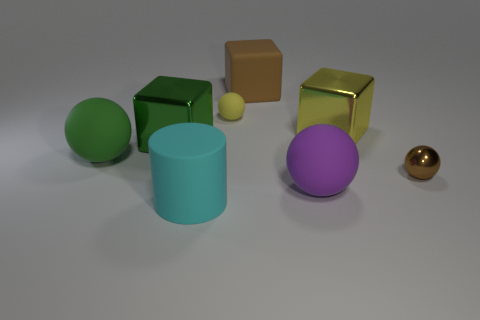What color is the other shiny cube that is the same size as the yellow metallic block?
Provide a short and direct response. Green. What number of things are either purple matte blocks or big matte things?
Your response must be concise. 4. There is a tiny yellow matte thing; are there any large green rubber balls in front of it?
Your answer should be compact. Yes. Is there a yellow thing made of the same material as the big brown block?
Provide a succinct answer. Yes. What size is the shiny thing that is the same color as the rubber cube?
Offer a terse response. Small. What number of spheres are blue matte things or tiny brown things?
Ensure brevity in your answer.  1. Is the number of tiny metallic things that are behind the large purple thing greater than the number of blocks that are behind the big brown matte object?
Provide a short and direct response. Yes. What number of big rubber cylinders have the same color as the tiny shiny object?
Your response must be concise. 0. There is a purple ball that is made of the same material as the yellow sphere; what size is it?
Provide a succinct answer. Large. What number of things are big things behind the large green block or large green objects?
Your answer should be compact. 4. 